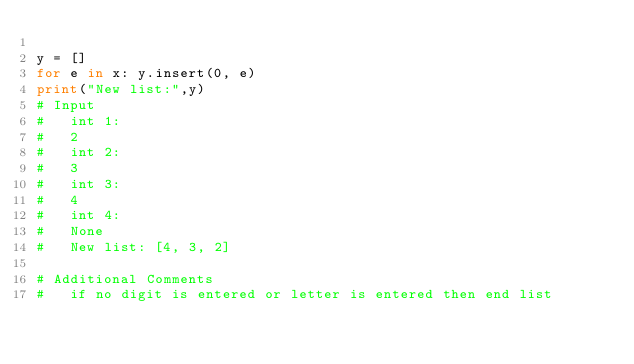Convert code to text. <code><loc_0><loc_0><loc_500><loc_500><_Python_>
y = []
for e in x: y.insert(0, e)
print("New list:",y)
# Input
#   int 1:
#   2
#   int 2:
#   3
#   int 3:
#   4
#   int 4:
#   None
#   New list: [4, 3, 2]

# Additional Comments
#   if no digit is entered or letter is entered then end list</code> 